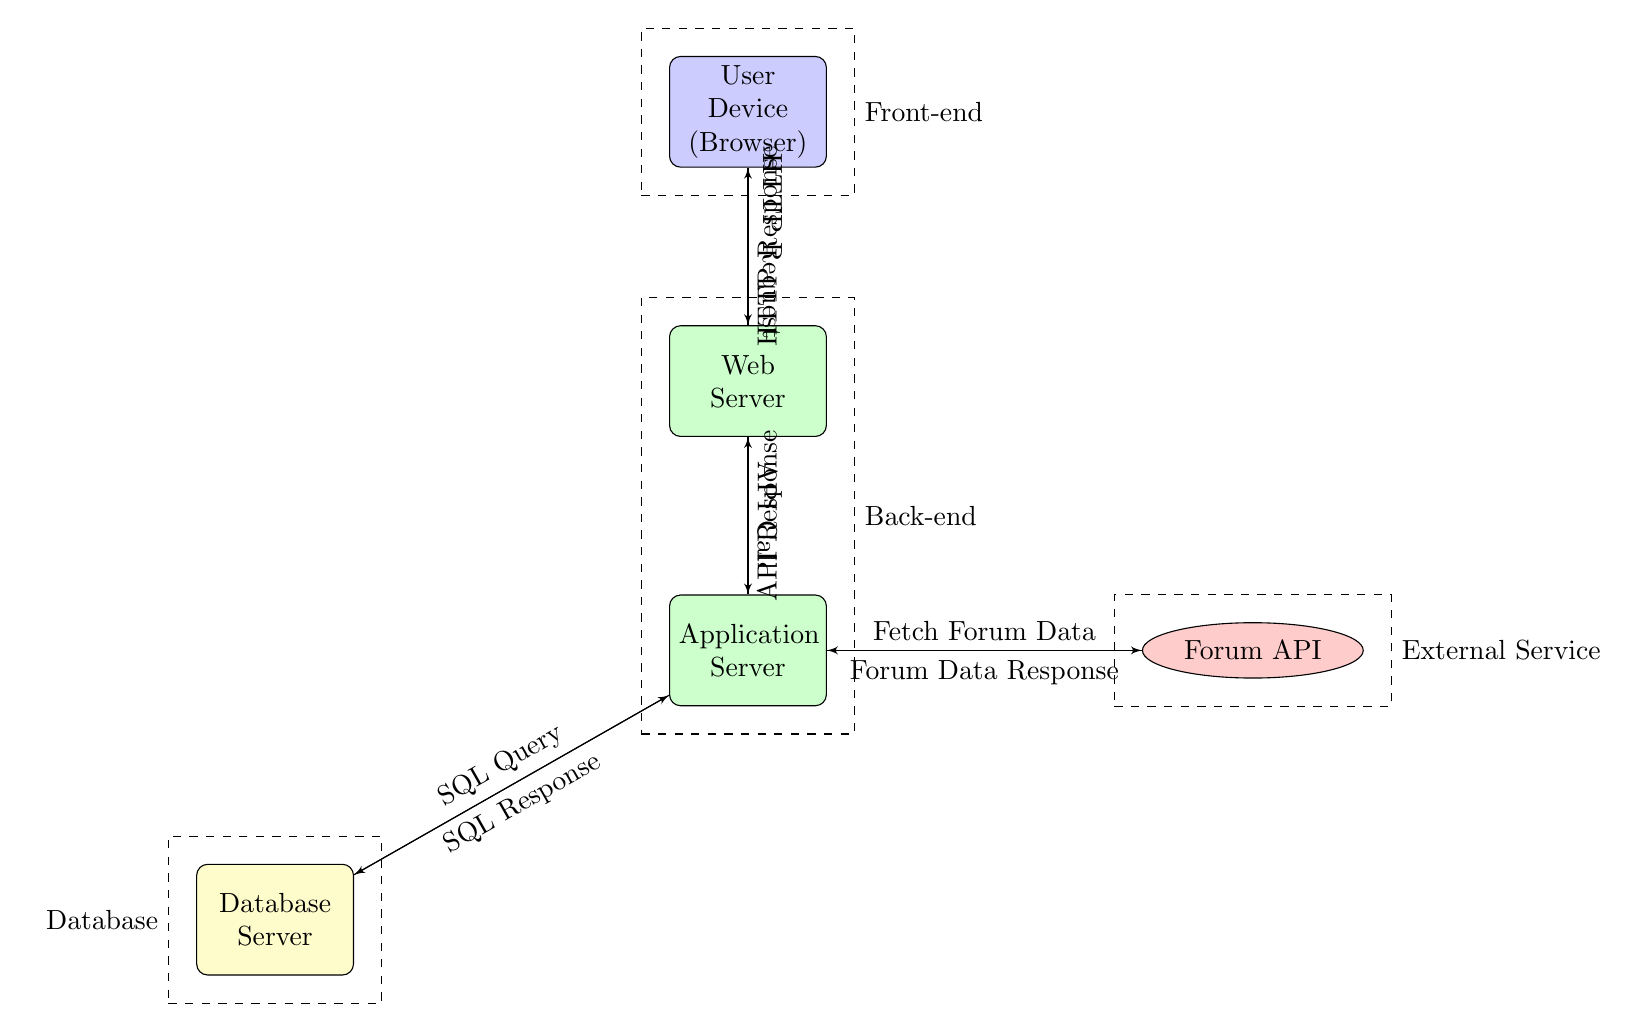What is the topmost node in the diagram? The topmost node in the diagram is the User Device (Browser), which is portrayed as the first entry point for the data flow.
Answer: User Device (Browser) How many nodes are there in total? Counting all the distinct blocks and clouds in the diagram, there are six nodes: User Device (Browser), Web Server, Application Server, Database Server, Forum API.
Answer: 6 What is the relationship between the Application Server and the Database Server? The Application Server sends an SQL Query to the Database Server and receives an SQL Response in return, illustrating a direct communication for data retrieval.
Answer: SQL Query Which tier does the Web Server belong to? The Web Server is grouped within the Back-end tier, as indicated by the dashed box encompassing it and the Application Server.
Answer: Back-end What type of response is received by the Application Server from the Forum API? The Application Server receives a Forum Data Response from the Forum API, which is designated for processing the fetched information.
Answer: Forum Data Response How does data flow from the User Device to the Web Server? Data flows from the User Device to the Web Server via an HTTP Request. This indicates the type of communication made by the client device to access web resources.
Answer: HTTP Request What is the role of the Forum API in this architecture? The Forum API functions as an external service that the Application Server can query to gather data about true crime forums, contributing to content aggregation.
Answer: External Service What does the dashed box labeled "Database" contain? The dashed box labeled "Database" contains the Database Server, which is responsible for storing and managing data for the application.
Answer: Database Server Which node does the Application Server send data to after processing? After processing, the Application Server sends an API Response back to the Web Server, indicating that the data has been packaged for the next stage in the data flow.
Answer: API Response 